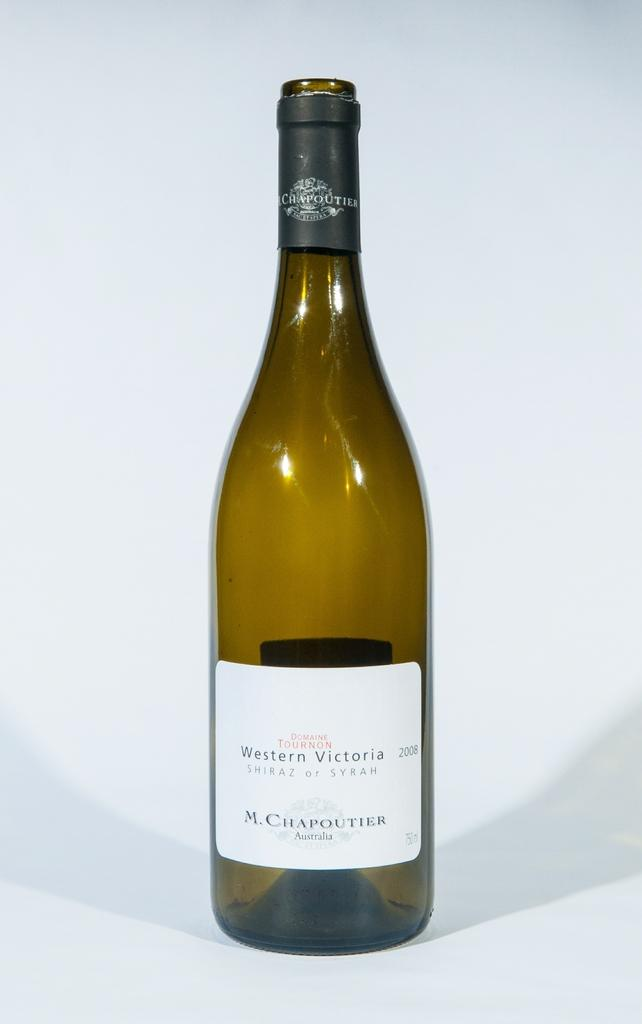What is the main object in the picture? There is a wine bottle in the picture. What is the color of the wine bottle? The wine bottle is gold in color. What is on the wine bottle? The wine bottle has a white label. What information is on the label? The label has the name "Western Victoria" on it. How does the wine bottle cause pain in the image? The wine bottle does not cause pain in the image; it is an inanimate object. 